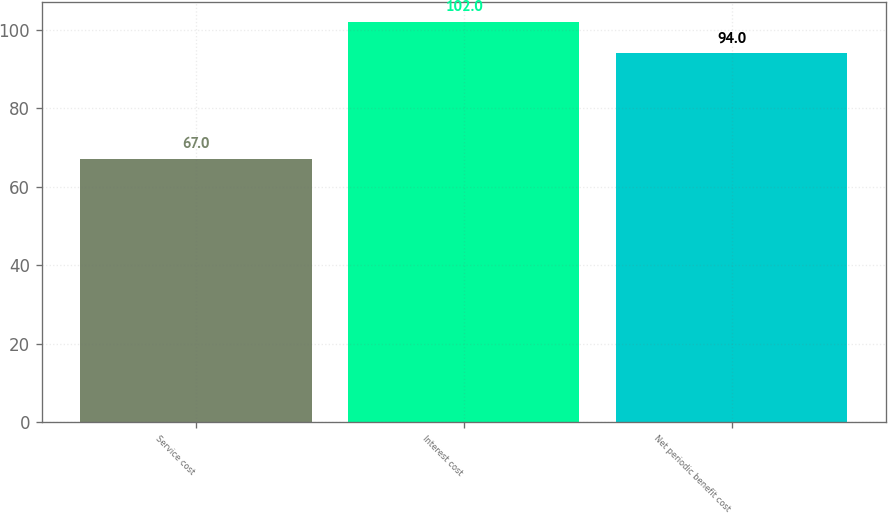Convert chart to OTSL. <chart><loc_0><loc_0><loc_500><loc_500><bar_chart><fcel>Service cost<fcel>Interest cost<fcel>Net periodic benefit cost<nl><fcel>67<fcel>102<fcel>94<nl></chart> 